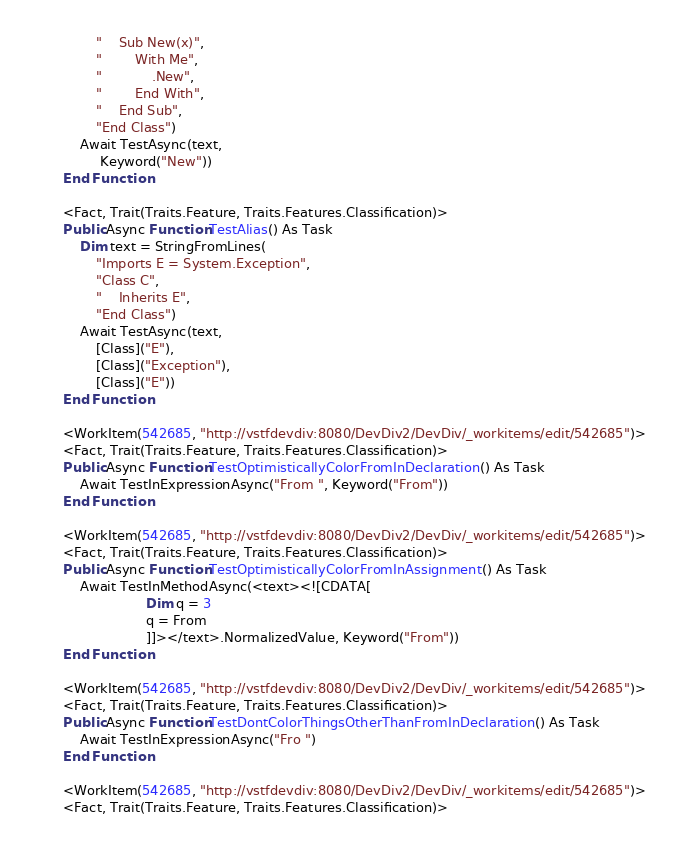<code> <loc_0><loc_0><loc_500><loc_500><_VisualBasic_>                "    Sub New(x)",
                "        With Me",
                "            .New",
                "        End With",
                "    End Sub",
                "End Class")
            Await TestAsync(text,
                 Keyword("New"))
        End Function

        <Fact, Trait(Traits.Feature, Traits.Features.Classification)>
        Public Async Function TestAlias() As Task
            Dim text = StringFromLines(
                "Imports E = System.Exception",
                "Class C",
                "    Inherits E",
                "End Class")
            Await TestAsync(text,
                [Class]("E"),
                [Class]("Exception"),
                [Class]("E"))
        End Function

        <WorkItem(542685, "http://vstfdevdiv:8080/DevDiv2/DevDiv/_workitems/edit/542685")>
        <Fact, Trait(Traits.Feature, Traits.Features.Classification)>
        Public Async Function TestOptimisticallyColorFromInDeclaration() As Task
            Await TestInExpressionAsync("From ", Keyword("From"))
        End Function

        <WorkItem(542685, "http://vstfdevdiv:8080/DevDiv2/DevDiv/_workitems/edit/542685")>
        <Fact, Trait(Traits.Feature, Traits.Features.Classification)>
        Public Async Function TestOptimisticallyColorFromInAssignment() As Task
            Await TestInMethodAsync(<text><![CDATA[
                            Dim q = 3
                            q = From 
                            ]]></text>.NormalizedValue, Keyword("From"))
        End Function

        <WorkItem(542685, "http://vstfdevdiv:8080/DevDiv2/DevDiv/_workitems/edit/542685")>
        <Fact, Trait(Traits.Feature, Traits.Features.Classification)>
        Public Async Function TestDontColorThingsOtherThanFromInDeclaration() As Task
            Await TestInExpressionAsync("Fro ")
        End Function

        <WorkItem(542685, "http://vstfdevdiv:8080/DevDiv2/DevDiv/_workitems/edit/542685")>
        <Fact, Trait(Traits.Feature, Traits.Features.Classification)></code> 